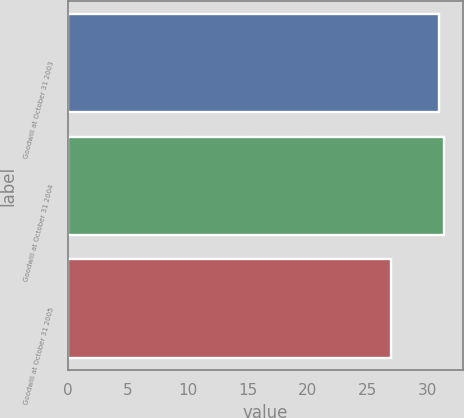Convert chart to OTSL. <chart><loc_0><loc_0><loc_500><loc_500><bar_chart><fcel>Goodwill at October 31 2003<fcel>Goodwill at October 31 2004<fcel>Goodwill at October 31 2005<nl><fcel>31<fcel>31.4<fcel>27<nl></chart> 